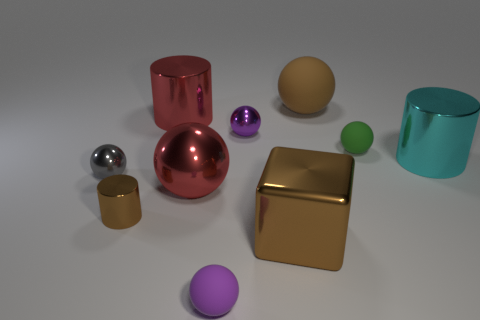Subtract all cyan metal cylinders. How many cylinders are left? 2 Subtract all cyan cylinders. How many purple spheres are left? 2 Subtract all cyan cylinders. How many cylinders are left? 2 Subtract all cubes. How many objects are left? 9 Subtract 1 cylinders. How many cylinders are left? 2 Subtract all big shiny cubes. Subtract all tiny green matte cylinders. How many objects are left? 9 Add 2 large metallic balls. How many large metallic balls are left? 3 Add 9 small green objects. How many small green objects exist? 10 Subtract 0 green blocks. How many objects are left? 10 Subtract all purple spheres. Subtract all red cubes. How many spheres are left? 4 